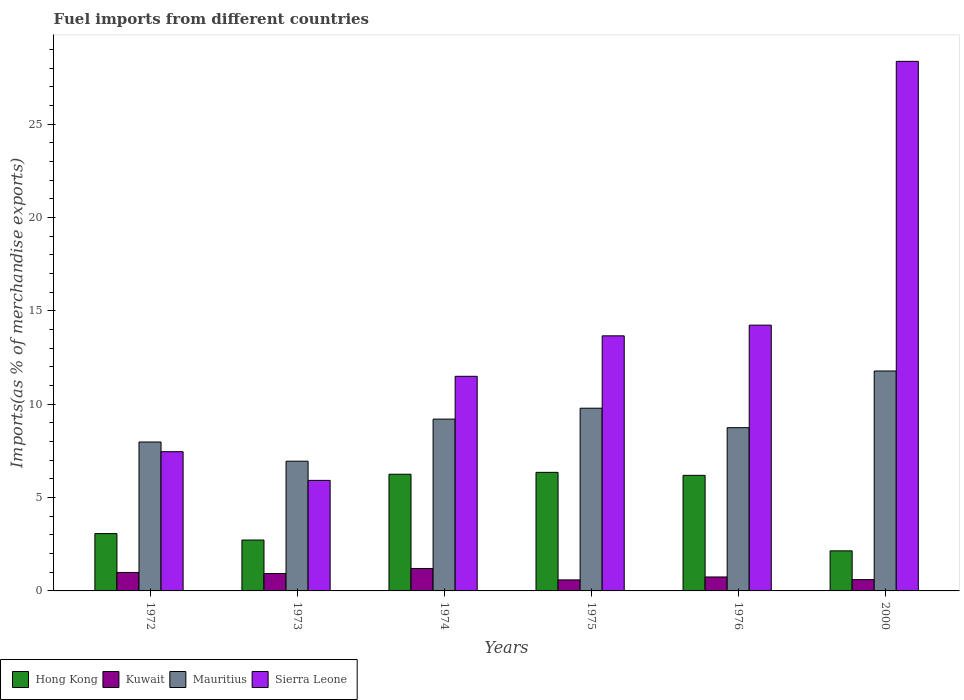How many different coloured bars are there?
Your response must be concise. 4. Are the number of bars per tick equal to the number of legend labels?
Offer a very short reply. Yes. How many bars are there on the 6th tick from the left?
Provide a short and direct response. 4. How many bars are there on the 3rd tick from the right?
Your response must be concise. 4. What is the label of the 5th group of bars from the left?
Make the answer very short. 1976. What is the percentage of imports to different countries in Kuwait in 1974?
Offer a terse response. 1.2. Across all years, what is the maximum percentage of imports to different countries in Hong Kong?
Your answer should be compact. 6.35. Across all years, what is the minimum percentage of imports to different countries in Mauritius?
Give a very brief answer. 6.95. In which year was the percentage of imports to different countries in Kuwait maximum?
Keep it short and to the point. 1974. What is the total percentage of imports to different countries in Sierra Leone in the graph?
Keep it short and to the point. 81.14. What is the difference between the percentage of imports to different countries in Sierra Leone in 1975 and that in 1976?
Give a very brief answer. -0.57. What is the difference between the percentage of imports to different countries in Kuwait in 1975 and the percentage of imports to different countries in Mauritius in 1973?
Provide a short and direct response. -6.36. What is the average percentage of imports to different countries in Mauritius per year?
Offer a terse response. 9.07. In the year 2000, what is the difference between the percentage of imports to different countries in Kuwait and percentage of imports to different countries in Sierra Leone?
Your response must be concise. -27.76. What is the ratio of the percentage of imports to different countries in Hong Kong in 1974 to that in 2000?
Provide a short and direct response. 2.91. Is the percentage of imports to different countries in Hong Kong in 1972 less than that in 1974?
Make the answer very short. Yes. Is the difference between the percentage of imports to different countries in Kuwait in 1972 and 1973 greater than the difference between the percentage of imports to different countries in Sierra Leone in 1972 and 1973?
Your response must be concise. No. What is the difference between the highest and the second highest percentage of imports to different countries in Kuwait?
Provide a succinct answer. 0.21. What is the difference between the highest and the lowest percentage of imports to different countries in Mauritius?
Keep it short and to the point. 4.83. In how many years, is the percentage of imports to different countries in Mauritius greater than the average percentage of imports to different countries in Mauritius taken over all years?
Your response must be concise. 3. What does the 2nd bar from the left in 1972 represents?
Ensure brevity in your answer.  Kuwait. What does the 4th bar from the right in 1973 represents?
Ensure brevity in your answer.  Hong Kong. How many bars are there?
Give a very brief answer. 24. Are all the bars in the graph horizontal?
Keep it short and to the point. No. How many years are there in the graph?
Your answer should be very brief. 6. Are the values on the major ticks of Y-axis written in scientific E-notation?
Make the answer very short. No. Does the graph contain any zero values?
Your answer should be very brief. No. Where does the legend appear in the graph?
Offer a very short reply. Bottom left. What is the title of the graph?
Your answer should be compact. Fuel imports from different countries. What is the label or title of the Y-axis?
Offer a terse response. Imports(as % of merchandise exports). What is the Imports(as % of merchandise exports) of Hong Kong in 1972?
Keep it short and to the point. 3.07. What is the Imports(as % of merchandise exports) in Kuwait in 1972?
Your answer should be compact. 0.99. What is the Imports(as % of merchandise exports) in Mauritius in 1972?
Your answer should be compact. 7.98. What is the Imports(as % of merchandise exports) in Sierra Leone in 1972?
Provide a succinct answer. 7.46. What is the Imports(as % of merchandise exports) of Hong Kong in 1973?
Offer a very short reply. 2.73. What is the Imports(as % of merchandise exports) in Kuwait in 1973?
Keep it short and to the point. 0.93. What is the Imports(as % of merchandise exports) in Mauritius in 1973?
Offer a terse response. 6.95. What is the Imports(as % of merchandise exports) in Sierra Leone in 1973?
Your response must be concise. 5.92. What is the Imports(as % of merchandise exports) in Hong Kong in 1974?
Offer a very short reply. 6.25. What is the Imports(as % of merchandise exports) of Kuwait in 1974?
Provide a succinct answer. 1.2. What is the Imports(as % of merchandise exports) of Mauritius in 1974?
Your answer should be compact. 9.2. What is the Imports(as % of merchandise exports) of Sierra Leone in 1974?
Give a very brief answer. 11.5. What is the Imports(as % of merchandise exports) of Hong Kong in 1975?
Your answer should be compact. 6.35. What is the Imports(as % of merchandise exports) in Kuwait in 1975?
Give a very brief answer. 0.59. What is the Imports(as % of merchandise exports) in Mauritius in 1975?
Your response must be concise. 9.79. What is the Imports(as % of merchandise exports) in Sierra Leone in 1975?
Provide a succinct answer. 13.66. What is the Imports(as % of merchandise exports) of Hong Kong in 1976?
Make the answer very short. 6.19. What is the Imports(as % of merchandise exports) in Kuwait in 1976?
Your answer should be compact. 0.75. What is the Imports(as % of merchandise exports) of Mauritius in 1976?
Make the answer very short. 8.74. What is the Imports(as % of merchandise exports) in Sierra Leone in 1976?
Your answer should be compact. 14.24. What is the Imports(as % of merchandise exports) of Hong Kong in 2000?
Keep it short and to the point. 2.15. What is the Imports(as % of merchandise exports) in Kuwait in 2000?
Offer a terse response. 0.61. What is the Imports(as % of merchandise exports) of Mauritius in 2000?
Offer a terse response. 11.78. What is the Imports(as % of merchandise exports) of Sierra Leone in 2000?
Your answer should be very brief. 28.37. Across all years, what is the maximum Imports(as % of merchandise exports) of Hong Kong?
Offer a terse response. 6.35. Across all years, what is the maximum Imports(as % of merchandise exports) in Kuwait?
Offer a very short reply. 1.2. Across all years, what is the maximum Imports(as % of merchandise exports) in Mauritius?
Offer a very short reply. 11.78. Across all years, what is the maximum Imports(as % of merchandise exports) in Sierra Leone?
Ensure brevity in your answer.  28.37. Across all years, what is the minimum Imports(as % of merchandise exports) of Hong Kong?
Ensure brevity in your answer.  2.15. Across all years, what is the minimum Imports(as % of merchandise exports) of Kuwait?
Your answer should be compact. 0.59. Across all years, what is the minimum Imports(as % of merchandise exports) of Mauritius?
Offer a very short reply. 6.95. Across all years, what is the minimum Imports(as % of merchandise exports) of Sierra Leone?
Make the answer very short. 5.92. What is the total Imports(as % of merchandise exports) in Hong Kong in the graph?
Give a very brief answer. 26.74. What is the total Imports(as % of merchandise exports) of Kuwait in the graph?
Ensure brevity in your answer.  5.07. What is the total Imports(as % of merchandise exports) of Mauritius in the graph?
Keep it short and to the point. 54.44. What is the total Imports(as % of merchandise exports) in Sierra Leone in the graph?
Provide a succinct answer. 81.14. What is the difference between the Imports(as % of merchandise exports) in Hong Kong in 1972 and that in 1973?
Your answer should be compact. 0.35. What is the difference between the Imports(as % of merchandise exports) of Kuwait in 1972 and that in 1973?
Make the answer very short. 0.06. What is the difference between the Imports(as % of merchandise exports) in Mauritius in 1972 and that in 1973?
Ensure brevity in your answer.  1.03. What is the difference between the Imports(as % of merchandise exports) in Sierra Leone in 1972 and that in 1973?
Give a very brief answer. 1.54. What is the difference between the Imports(as % of merchandise exports) of Hong Kong in 1972 and that in 1974?
Your answer should be very brief. -3.18. What is the difference between the Imports(as % of merchandise exports) of Kuwait in 1972 and that in 1974?
Your answer should be very brief. -0.21. What is the difference between the Imports(as % of merchandise exports) of Mauritius in 1972 and that in 1974?
Your response must be concise. -1.23. What is the difference between the Imports(as % of merchandise exports) in Sierra Leone in 1972 and that in 1974?
Your answer should be very brief. -4.04. What is the difference between the Imports(as % of merchandise exports) in Hong Kong in 1972 and that in 1975?
Offer a very short reply. -3.28. What is the difference between the Imports(as % of merchandise exports) of Kuwait in 1972 and that in 1975?
Your response must be concise. 0.4. What is the difference between the Imports(as % of merchandise exports) of Mauritius in 1972 and that in 1975?
Keep it short and to the point. -1.81. What is the difference between the Imports(as % of merchandise exports) of Sierra Leone in 1972 and that in 1975?
Offer a terse response. -6.21. What is the difference between the Imports(as % of merchandise exports) in Hong Kong in 1972 and that in 1976?
Your response must be concise. -3.12. What is the difference between the Imports(as % of merchandise exports) of Kuwait in 1972 and that in 1976?
Your response must be concise. 0.24. What is the difference between the Imports(as % of merchandise exports) of Mauritius in 1972 and that in 1976?
Ensure brevity in your answer.  -0.77. What is the difference between the Imports(as % of merchandise exports) of Sierra Leone in 1972 and that in 1976?
Ensure brevity in your answer.  -6.78. What is the difference between the Imports(as % of merchandise exports) of Hong Kong in 1972 and that in 2000?
Your answer should be compact. 0.93. What is the difference between the Imports(as % of merchandise exports) of Kuwait in 1972 and that in 2000?
Your response must be concise. 0.39. What is the difference between the Imports(as % of merchandise exports) in Mauritius in 1972 and that in 2000?
Provide a short and direct response. -3.8. What is the difference between the Imports(as % of merchandise exports) of Sierra Leone in 1972 and that in 2000?
Give a very brief answer. -20.91. What is the difference between the Imports(as % of merchandise exports) in Hong Kong in 1973 and that in 1974?
Your answer should be compact. -3.52. What is the difference between the Imports(as % of merchandise exports) of Kuwait in 1973 and that in 1974?
Offer a terse response. -0.27. What is the difference between the Imports(as % of merchandise exports) of Mauritius in 1973 and that in 1974?
Provide a succinct answer. -2.25. What is the difference between the Imports(as % of merchandise exports) in Sierra Leone in 1973 and that in 1974?
Your answer should be compact. -5.57. What is the difference between the Imports(as % of merchandise exports) of Hong Kong in 1973 and that in 1975?
Provide a succinct answer. -3.63. What is the difference between the Imports(as % of merchandise exports) in Kuwait in 1973 and that in 1975?
Your answer should be very brief. 0.34. What is the difference between the Imports(as % of merchandise exports) in Mauritius in 1973 and that in 1975?
Ensure brevity in your answer.  -2.84. What is the difference between the Imports(as % of merchandise exports) in Sierra Leone in 1973 and that in 1975?
Give a very brief answer. -7.74. What is the difference between the Imports(as % of merchandise exports) of Hong Kong in 1973 and that in 1976?
Provide a short and direct response. -3.46. What is the difference between the Imports(as % of merchandise exports) of Kuwait in 1973 and that in 1976?
Provide a succinct answer. 0.18. What is the difference between the Imports(as % of merchandise exports) of Mauritius in 1973 and that in 1976?
Provide a succinct answer. -1.8. What is the difference between the Imports(as % of merchandise exports) in Sierra Leone in 1973 and that in 1976?
Give a very brief answer. -8.31. What is the difference between the Imports(as % of merchandise exports) of Hong Kong in 1973 and that in 2000?
Your answer should be very brief. 0.58. What is the difference between the Imports(as % of merchandise exports) in Kuwait in 1973 and that in 2000?
Ensure brevity in your answer.  0.33. What is the difference between the Imports(as % of merchandise exports) in Mauritius in 1973 and that in 2000?
Give a very brief answer. -4.83. What is the difference between the Imports(as % of merchandise exports) of Sierra Leone in 1973 and that in 2000?
Provide a short and direct response. -22.44. What is the difference between the Imports(as % of merchandise exports) in Hong Kong in 1974 and that in 1975?
Give a very brief answer. -0.1. What is the difference between the Imports(as % of merchandise exports) in Kuwait in 1974 and that in 1975?
Offer a very short reply. 0.61. What is the difference between the Imports(as % of merchandise exports) of Mauritius in 1974 and that in 1975?
Offer a very short reply. -0.58. What is the difference between the Imports(as % of merchandise exports) in Sierra Leone in 1974 and that in 1975?
Make the answer very short. -2.17. What is the difference between the Imports(as % of merchandise exports) in Hong Kong in 1974 and that in 1976?
Keep it short and to the point. 0.06. What is the difference between the Imports(as % of merchandise exports) of Kuwait in 1974 and that in 1976?
Give a very brief answer. 0.46. What is the difference between the Imports(as % of merchandise exports) of Mauritius in 1974 and that in 1976?
Your response must be concise. 0.46. What is the difference between the Imports(as % of merchandise exports) of Sierra Leone in 1974 and that in 1976?
Keep it short and to the point. -2.74. What is the difference between the Imports(as % of merchandise exports) in Hong Kong in 1974 and that in 2000?
Provide a short and direct response. 4.1. What is the difference between the Imports(as % of merchandise exports) of Kuwait in 1974 and that in 2000?
Your answer should be very brief. 0.6. What is the difference between the Imports(as % of merchandise exports) of Mauritius in 1974 and that in 2000?
Give a very brief answer. -2.58. What is the difference between the Imports(as % of merchandise exports) of Sierra Leone in 1974 and that in 2000?
Make the answer very short. -16.87. What is the difference between the Imports(as % of merchandise exports) of Hong Kong in 1975 and that in 1976?
Offer a terse response. 0.16. What is the difference between the Imports(as % of merchandise exports) of Kuwait in 1975 and that in 1976?
Offer a very short reply. -0.16. What is the difference between the Imports(as % of merchandise exports) in Mauritius in 1975 and that in 1976?
Make the answer very short. 1.04. What is the difference between the Imports(as % of merchandise exports) of Sierra Leone in 1975 and that in 1976?
Give a very brief answer. -0.57. What is the difference between the Imports(as % of merchandise exports) in Hong Kong in 1975 and that in 2000?
Your answer should be very brief. 4.2. What is the difference between the Imports(as % of merchandise exports) in Kuwait in 1975 and that in 2000?
Your answer should be compact. -0.01. What is the difference between the Imports(as % of merchandise exports) in Mauritius in 1975 and that in 2000?
Your answer should be very brief. -1.99. What is the difference between the Imports(as % of merchandise exports) in Sierra Leone in 1975 and that in 2000?
Offer a very short reply. -14.7. What is the difference between the Imports(as % of merchandise exports) in Hong Kong in 1976 and that in 2000?
Offer a terse response. 4.04. What is the difference between the Imports(as % of merchandise exports) of Kuwait in 1976 and that in 2000?
Make the answer very short. 0.14. What is the difference between the Imports(as % of merchandise exports) in Mauritius in 1976 and that in 2000?
Make the answer very short. -3.04. What is the difference between the Imports(as % of merchandise exports) in Sierra Leone in 1976 and that in 2000?
Give a very brief answer. -14.13. What is the difference between the Imports(as % of merchandise exports) in Hong Kong in 1972 and the Imports(as % of merchandise exports) in Kuwait in 1973?
Give a very brief answer. 2.14. What is the difference between the Imports(as % of merchandise exports) of Hong Kong in 1972 and the Imports(as % of merchandise exports) of Mauritius in 1973?
Keep it short and to the point. -3.88. What is the difference between the Imports(as % of merchandise exports) of Hong Kong in 1972 and the Imports(as % of merchandise exports) of Sierra Leone in 1973?
Offer a very short reply. -2.85. What is the difference between the Imports(as % of merchandise exports) of Kuwait in 1972 and the Imports(as % of merchandise exports) of Mauritius in 1973?
Provide a short and direct response. -5.96. What is the difference between the Imports(as % of merchandise exports) of Kuwait in 1972 and the Imports(as % of merchandise exports) of Sierra Leone in 1973?
Provide a short and direct response. -4.93. What is the difference between the Imports(as % of merchandise exports) of Mauritius in 1972 and the Imports(as % of merchandise exports) of Sierra Leone in 1973?
Make the answer very short. 2.06. What is the difference between the Imports(as % of merchandise exports) in Hong Kong in 1972 and the Imports(as % of merchandise exports) in Kuwait in 1974?
Keep it short and to the point. 1.87. What is the difference between the Imports(as % of merchandise exports) of Hong Kong in 1972 and the Imports(as % of merchandise exports) of Mauritius in 1974?
Ensure brevity in your answer.  -6.13. What is the difference between the Imports(as % of merchandise exports) in Hong Kong in 1972 and the Imports(as % of merchandise exports) in Sierra Leone in 1974?
Offer a very short reply. -8.42. What is the difference between the Imports(as % of merchandise exports) of Kuwait in 1972 and the Imports(as % of merchandise exports) of Mauritius in 1974?
Your answer should be compact. -8.21. What is the difference between the Imports(as % of merchandise exports) in Kuwait in 1972 and the Imports(as % of merchandise exports) in Sierra Leone in 1974?
Offer a terse response. -10.51. What is the difference between the Imports(as % of merchandise exports) of Mauritius in 1972 and the Imports(as % of merchandise exports) of Sierra Leone in 1974?
Keep it short and to the point. -3.52. What is the difference between the Imports(as % of merchandise exports) in Hong Kong in 1972 and the Imports(as % of merchandise exports) in Kuwait in 1975?
Offer a terse response. 2.48. What is the difference between the Imports(as % of merchandise exports) in Hong Kong in 1972 and the Imports(as % of merchandise exports) in Mauritius in 1975?
Offer a very short reply. -6.72. What is the difference between the Imports(as % of merchandise exports) in Hong Kong in 1972 and the Imports(as % of merchandise exports) in Sierra Leone in 1975?
Make the answer very short. -10.59. What is the difference between the Imports(as % of merchandise exports) of Kuwait in 1972 and the Imports(as % of merchandise exports) of Mauritius in 1975?
Keep it short and to the point. -8.8. What is the difference between the Imports(as % of merchandise exports) of Kuwait in 1972 and the Imports(as % of merchandise exports) of Sierra Leone in 1975?
Make the answer very short. -12.67. What is the difference between the Imports(as % of merchandise exports) in Mauritius in 1972 and the Imports(as % of merchandise exports) in Sierra Leone in 1975?
Give a very brief answer. -5.69. What is the difference between the Imports(as % of merchandise exports) of Hong Kong in 1972 and the Imports(as % of merchandise exports) of Kuwait in 1976?
Your answer should be very brief. 2.32. What is the difference between the Imports(as % of merchandise exports) of Hong Kong in 1972 and the Imports(as % of merchandise exports) of Mauritius in 1976?
Make the answer very short. -5.67. What is the difference between the Imports(as % of merchandise exports) in Hong Kong in 1972 and the Imports(as % of merchandise exports) in Sierra Leone in 1976?
Ensure brevity in your answer.  -11.16. What is the difference between the Imports(as % of merchandise exports) of Kuwait in 1972 and the Imports(as % of merchandise exports) of Mauritius in 1976?
Provide a succinct answer. -7.75. What is the difference between the Imports(as % of merchandise exports) in Kuwait in 1972 and the Imports(as % of merchandise exports) in Sierra Leone in 1976?
Give a very brief answer. -13.24. What is the difference between the Imports(as % of merchandise exports) of Mauritius in 1972 and the Imports(as % of merchandise exports) of Sierra Leone in 1976?
Keep it short and to the point. -6.26. What is the difference between the Imports(as % of merchandise exports) in Hong Kong in 1972 and the Imports(as % of merchandise exports) in Kuwait in 2000?
Make the answer very short. 2.47. What is the difference between the Imports(as % of merchandise exports) of Hong Kong in 1972 and the Imports(as % of merchandise exports) of Mauritius in 2000?
Keep it short and to the point. -8.71. What is the difference between the Imports(as % of merchandise exports) of Hong Kong in 1972 and the Imports(as % of merchandise exports) of Sierra Leone in 2000?
Keep it short and to the point. -25.29. What is the difference between the Imports(as % of merchandise exports) of Kuwait in 1972 and the Imports(as % of merchandise exports) of Mauritius in 2000?
Your response must be concise. -10.79. What is the difference between the Imports(as % of merchandise exports) in Kuwait in 1972 and the Imports(as % of merchandise exports) in Sierra Leone in 2000?
Offer a very short reply. -27.38. What is the difference between the Imports(as % of merchandise exports) in Mauritius in 1972 and the Imports(as % of merchandise exports) in Sierra Leone in 2000?
Provide a short and direct response. -20.39. What is the difference between the Imports(as % of merchandise exports) in Hong Kong in 1973 and the Imports(as % of merchandise exports) in Kuwait in 1974?
Make the answer very short. 1.52. What is the difference between the Imports(as % of merchandise exports) in Hong Kong in 1973 and the Imports(as % of merchandise exports) in Mauritius in 1974?
Provide a short and direct response. -6.48. What is the difference between the Imports(as % of merchandise exports) in Hong Kong in 1973 and the Imports(as % of merchandise exports) in Sierra Leone in 1974?
Your answer should be compact. -8.77. What is the difference between the Imports(as % of merchandise exports) in Kuwait in 1973 and the Imports(as % of merchandise exports) in Mauritius in 1974?
Your response must be concise. -8.27. What is the difference between the Imports(as % of merchandise exports) of Kuwait in 1973 and the Imports(as % of merchandise exports) of Sierra Leone in 1974?
Your answer should be compact. -10.57. What is the difference between the Imports(as % of merchandise exports) of Mauritius in 1973 and the Imports(as % of merchandise exports) of Sierra Leone in 1974?
Offer a terse response. -4.55. What is the difference between the Imports(as % of merchandise exports) of Hong Kong in 1973 and the Imports(as % of merchandise exports) of Kuwait in 1975?
Your answer should be compact. 2.14. What is the difference between the Imports(as % of merchandise exports) in Hong Kong in 1973 and the Imports(as % of merchandise exports) in Mauritius in 1975?
Make the answer very short. -7.06. What is the difference between the Imports(as % of merchandise exports) in Hong Kong in 1973 and the Imports(as % of merchandise exports) in Sierra Leone in 1975?
Your answer should be compact. -10.94. What is the difference between the Imports(as % of merchandise exports) of Kuwait in 1973 and the Imports(as % of merchandise exports) of Mauritius in 1975?
Keep it short and to the point. -8.86. What is the difference between the Imports(as % of merchandise exports) of Kuwait in 1973 and the Imports(as % of merchandise exports) of Sierra Leone in 1975?
Offer a terse response. -12.73. What is the difference between the Imports(as % of merchandise exports) of Mauritius in 1973 and the Imports(as % of merchandise exports) of Sierra Leone in 1975?
Your answer should be compact. -6.71. What is the difference between the Imports(as % of merchandise exports) of Hong Kong in 1973 and the Imports(as % of merchandise exports) of Kuwait in 1976?
Make the answer very short. 1.98. What is the difference between the Imports(as % of merchandise exports) of Hong Kong in 1973 and the Imports(as % of merchandise exports) of Mauritius in 1976?
Your answer should be very brief. -6.02. What is the difference between the Imports(as % of merchandise exports) of Hong Kong in 1973 and the Imports(as % of merchandise exports) of Sierra Leone in 1976?
Provide a succinct answer. -11.51. What is the difference between the Imports(as % of merchandise exports) of Kuwait in 1973 and the Imports(as % of merchandise exports) of Mauritius in 1976?
Your answer should be compact. -7.81. What is the difference between the Imports(as % of merchandise exports) of Kuwait in 1973 and the Imports(as % of merchandise exports) of Sierra Leone in 1976?
Provide a succinct answer. -13.31. What is the difference between the Imports(as % of merchandise exports) in Mauritius in 1973 and the Imports(as % of merchandise exports) in Sierra Leone in 1976?
Your response must be concise. -7.29. What is the difference between the Imports(as % of merchandise exports) in Hong Kong in 1973 and the Imports(as % of merchandise exports) in Kuwait in 2000?
Your response must be concise. 2.12. What is the difference between the Imports(as % of merchandise exports) of Hong Kong in 1973 and the Imports(as % of merchandise exports) of Mauritius in 2000?
Make the answer very short. -9.05. What is the difference between the Imports(as % of merchandise exports) in Hong Kong in 1973 and the Imports(as % of merchandise exports) in Sierra Leone in 2000?
Your answer should be very brief. -25.64. What is the difference between the Imports(as % of merchandise exports) of Kuwait in 1973 and the Imports(as % of merchandise exports) of Mauritius in 2000?
Provide a succinct answer. -10.85. What is the difference between the Imports(as % of merchandise exports) in Kuwait in 1973 and the Imports(as % of merchandise exports) in Sierra Leone in 2000?
Ensure brevity in your answer.  -27.44. What is the difference between the Imports(as % of merchandise exports) in Mauritius in 1973 and the Imports(as % of merchandise exports) in Sierra Leone in 2000?
Give a very brief answer. -21.42. What is the difference between the Imports(as % of merchandise exports) of Hong Kong in 1974 and the Imports(as % of merchandise exports) of Kuwait in 1975?
Your answer should be compact. 5.66. What is the difference between the Imports(as % of merchandise exports) of Hong Kong in 1974 and the Imports(as % of merchandise exports) of Mauritius in 1975?
Give a very brief answer. -3.54. What is the difference between the Imports(as % of merchandise exports) in Hong Kong in 1974 and the Imports(as % of merchandise exports) in Sierra Leone in 1975?
Offer a terse response. -7.41. What is the difference between the Imports(as % of merchandise exports) of Kuwait in 1974 and the Imports(as % of merchandise exports) of Mauritius in 1975?
Provide a short and direct response. -8.58. What is the difference between the Imports(as % of merchandise exports) in Kuwait in 1974 and the Imports(as % of merchandise exports) in Sierra Leone in 1975?
Your response must be concise. -12.46. What is the difference between the Imports(as % of merchandise exports) of Mauritius in 1974 and the Imports(as % of merchandise exports) of Sierra Leone in 1975?
Keep it short and to the point. -4.46. What is the difference between the Imports(as % of merchandise exports) of Hong Kong in 1974 and the Imports(as % of merchandise exports) of Kuwait in 1976?
Make the answer very short. 5.5. What is the difference between the Imports(as % of merchandise exports) of Hong Kong in 1974 and the Imports(as % of merchandise exports) of Mauritius in 1976?
Your response must be concise. -2.49. What is the difference between the Imports(as % of merchandise exports) of Hong Kong in 1974 and the Imports(as % of merchandise exports) of Sierra Leone in 1976?
Provide a succinct answer. -7.99. What is the difference between the Imports(as % of merchandise exports) in Kuwait in 1974 and the Imports(as % of merchandise exports) in Mauritius in 1976?
Provide a succinct answer. -7.54. What is the difference between the Imports(as % of merchandise exports) in Kuwait in 1974 and the Imports(as % of merchandise exports) in Sierra Leone in 1976?
Offer a terse response. -13.03. What is the difference between the Imports(as % of merchandise exports) in Mauritius in 1974 and the Imports(as % of merchandise exports) in Sierra Leone in 1976?
Your answer should be very brief. -5.03. What is the difference between the Imports(as % of merchandise exports) of Hong Kong in 1974 and the Imports(as % of merchandise exports) of Kuwait in 2000?
Provide a short and direct response. 5.65. What is the difference between the Imports(as % of merchandise exports) in Hong Kong in 1974 and the Imports(as % of merchandise exports) in Mauritius in 2000?
Provide a succinct answer. -5.53. What is the difference between the Imports(as % of merchandise exports) of Hong Kong in 1974 and the Imports(as % of merchandise exports) of Sierra Leone in 2000?
Your answer should be compact. -22.12. What is the difference between the Imports(as % of merchandise exports) in Kuwait in 1974 and the Imports(as % of merchandise exports) in Mauritius in 2000?
Offer a terse response. -10.58. What is the difference between the Imports(as % of merchandise exports) of Kuwait in 1974 and the Imports(as % of merchandise exports) of Sierra Leone in 2000?
Your answer should be compact. -27.16. What is the difference between the Imports(as % of merchandise exports) in Mauritius in 1974 and the Imports(as % of merchandise exports) in Sierra Leone in 2000?
Your answer should be very brief. -19.16. What is the difference between the Imports(as % of merchandise exports) in Hong Kong in 1975 and the Imports(as % of merchandise exports) in Kuwait in 1976?
Offer a very short reply. 5.6. What is the difference between the Imports(as % of merchandise exports) of Hong Kong in 1975 and the Imports(as % of merchandise exports) of Mauritius in 1976?
Provide a succinct answer. -2.39. What is the difference between the Imports(as % of merchandise exports) in Hong Kong in 1975 and the Imports(as % of merchandise exports) in Sierra Leone in 1976?
Provide a short and direct response. -7.88. What is the difference between the Imports(as % of merchandise exports) in Kuwait in 1975 and the Imports(as % of merchandise exports) in Mauritius in 1976?
Keep it short and to the point. -8.15. What is the difference between the Imports(as % of merchandise exports) of Kuwait in 1975 and the Imports(as % of merchandise exports) of Sierra Leone in 1976?
Your answer should be very brief. -13.65. What is the difference between the Imports(as % of merchandise exports) of Mauritius in 1975 and the Imports(as % of merchandise exports) of Sierra Leone in 1976?
Your answer should be very brief. -4.45. What is the difference between the Imports(as % of merchandise exports) in Hong Kong in 1975 and the Imports(as % of merchandise exports) in Kuwait in 2000?
Give a very brief answer. 5.75. What is the difference between the Imports(as % of merchandise exports) of Hong Kong in 1975 and the Imports(as % of merchandise exports) of Mauritius in 2000?
Keep it short and to the point. -5.43. What is the difference between the Imports(as % of merchandise exports) of Hong Kong in 1975 and the Imports(as % of merchandise exports) of Sierra Leone in 2000?
Give a very brief answer. -22.02. What is the difference between the Imports(as % of merchandise exports) in Kuwait in 1975 and the Imports(as % of merchandise exports) in Mauritius in 2000?
Ensure brevity in your answer.  -11.19. What is the difference between the Imports(as % of merchandise exports) of Kuwait in 1975 and the Imports(as % of merchandise exports) of Sierra Leone in 2000?
Offer a very short reply. -27.78. What is the difference between the Imports(as % of merchandise exports) of Mauritius in 1975 and the Imports(as % of merchandise exports) of Sierra Leone in 2000?
Your response must be concise. -18.58. What is the difference between the Imports(as % of merchandise exports) of Hong Kong in 1976 and the Imports(as % of merchandise exports) of Kuwait in 2000?
Make the answer very short. 5.59. What is the difference between the Imports(as % of merchandise exports) of Hong Kong in 1976 and the Imports(as % of merchandise exports) of Mauritius in 2000?
Your response must be concise. -5.59. What is the difference between the Imports(as % of merchandise exports) of Hong Kong in 1976 and the Imports(as % of merchandise exports) of Sierra Leone in 2000?
Offer a terse response. -22.18. What is the difference between the Imports(as % of merchandise exports) in Kuwait in 1976 and the Imports(as % of merchandise exports) in Mauritius in 2000?
Ensure brevity in your answer.  -11.03. What is the difference between the Imports(as % of merchandise exports) in Kuwait in 1976 and the Imports(as % of merchandise exports) in Sierra Leone in 2000?
Your response must be concise. -27.62. What is the difference between the Imports(as % of merchandise exports) of Mauritius in 1976 and the Imports(as % of merchandise exports) of Sierra Leone in 2000?
Give a very brief answer. -19.62. What is the average Imports(as % of merchandise exports) in Hong Kong per year?
Your response must be concise. 4.46. What is the average Imports(as % of merchandise exports) in Kuwait per year?
Offer a terse response. 0.84. What is the average Imports(as % of merchandise exports) in Mauritius per year?
Offer a very short reply. 9.07. What is the average Imports(as % of merchandise exports) of Sierra Leone per year?
Your response must be concise. 13.52. In the year 1972, what is the difference between the Imports(as % of merchandise exports) of Hong Kong and Imports(as % of merchandise exports) of Kuwait?
Offer a terse response. 2.08. In the year 1972, what is the difference between the Imports(as % of merchandise exports) in Hong Kong and Imports(as % of merchandise exports) in Mauritius?
Make the answer very short. -4.91. In the year 1972, what is the difference between the Imports(as % of merchandise exports) of Hong Kong and Imports(as % of merchandise exports) of Sierra Leone?
Give a very brief answer. -4.39. In the year 1972, what is the difference between the Imports(as % of merchandise exports) in Kuwait and Imports(as % of merchandise exports) in Mauritius?
Offer a terse response. -6.99. In the year 1972, what is the difference between the Imports(as % of merchandise exports) of Kuwait and Imports(as % of merchandise exports) of Sierra Leone?
Provide a short and direct response. -6.47. In the year 1972, what is the difference between the Imports(as % of merchandise exports) of Mauritius and Imports(as % of merchandise exports) of Sierra Leone?
Give a very brief answer. 0.52. In the year 1973, what is the difference between the Imports(as % of merchandise exports) in Hong Kong and Imports(as % of merchandise exports) in Kuwait?
Your answer should be very brief. 1.8. In the year 1973, what is the difference between the Imports(as % of merchandise exports) of Hong Kong and Imports(as % of merchandise exports) of Mauritius?
Keep it short and to the point. -4.22. In the year 1973, what is the difference between the Imports(as % of merchandise exports) in Hong Kong and Imports(as % of merchandise exports) in Sierra Leone?
Your answer should be very brief. -3.2. In the year 1973, what is the difference between the Imports(as % of merchandise exports) of Kuwait and Imports(as % of merchandise exports) of Mauritius?
Keep it short and to the point. -6.02. In the year 1973, what is the difference between the Imports(as % of merchandise exports) of Kuwait and Imports(as % of merchandise exports) of Sierra Leone?
Offer a terse response. -4.99. In the year 1973, what is the difference between the Imports(as % of merchandise exports) in Mauritius and Imports(as % of merchandise exports) in Sierra Leone?
Give a very brief answer. 1.03. In the year 1974, what is the difference between the Imports(as % of merchandise exports) of Hong Kong and Imports(as % of merchandise exports) of Kuwait?
Make the answer very short. 5.05. In the year 1974, what is the difference between the Imports(as % of merchandise exports) in Hong Kong and Imports(as % of merchandise exports) in Mauritius?
Provide a short and direct response. -2.95. In the year 1974, what is the difference between the Imports(as % of merchandise exports) in Hong Kong and Imports(as % of merchandise exports) in Sierra Leone?
Ensure brevity in your answer.  -5.25. In the year 1974, what is the difference between the Imports(as % of merchandise exports) of Kuwait and Imports(as % of merchandise exports) of Mauritius?
Provide a succinct answer. -8. In the year 1974, what is the difference between the Imports(as % of merchandise exports) in Kuwait and Imports(as % of merchandise exports) in Sierra Leone?
Your answer should be very brief. -10.29. In the year 1974, what is the difference between the Imports(as % of merchandise exports) in Mauritius and Imports(as % of merchandise exports) in Sierra Leone?
Offer a very short reply. -2.29. In the year 1975, what is the difference between the Imports(as % of merchandise exports) of Hong Kong and Imports(as % of merchandise exports) of Kuwait?
Offer a very short reply. 5.76. In the year 1975, what is the difference between the Imports(as % of merchandise exports) in Hong Kong and Imports(as % of merchandise exports) in Mauritius?
Ensure brevity in your answer.  -3.44. In the year 1975, what is the difference between the Imports(as % of merchandise exports) in Hong Kong and Imports(as % of merchandise exports) in Sierra Leone?
Provide a short and direct response. -7.31. In the year 1975, what is the difference between the Imports(as % of merchandise exports) in Kuwait and Imports(as % of merchandise exports) in Mauritius?
Offer a terse response. -9.2. In the year 1975, what is the difference between the Imports(as % of merchandise exports) in Kuwait and Imports(as % of merchandise exports) in Sierra Leone?
Provide a short and direct response. -13.07. In the year 1975, what is the difference between the Imports(as % of merchandise exports) of Mauritius and Imports(as % of merchandise exports) of Sierra Leone?
Your answer should be very brief. -3.88. In the year 1976, what is the difference between the Imports(as % of merchandise exports) of Hong Kong and Imports(as % of merchandise exports) of Kuwait?
Give a very brief answer. 5.44. In the year 1976, what is the difference between the Imports(as % of merchandise exports) of Hong Kong and Imports(as % of merchandise exports) of Mauritius?
Offer a terse response. -2.55. In the year 1976, what is the difference between the Imports(as % of merchandise exports) in Hong Kong and Imports(as % of merchandise exports) in Sierra Leone?
Ensure brevity in your answer.  -8.04. In the year 1976, what is the difference between the Imports(as % of merchandise exports) of Kuwait and Imports(as % of merchandise exports) of Mauritius?
Provide a succinct answer. -8. In the year 1976, what is the difference between the Imports(as % of merchandise exports) in Kuwait and Imports(as % of merchandise exports) in Sierra Leone?
Give a very brief answer. -13.49. In the year 1976, what is the difference between the Imports(as % of merchandise exports) in Mauritius and Imports(as % of merchandise exports) in Sierra Leone?
Make the answer very short. -5.49. In the year 2000, what is the difference between the Imports(as % of merchandise exports) of Hong Kong and Imports(as % of merchandise exports) of Kuwait?
Give a very brief answer. 1.54. In the year 2000, what is the difference between the Imports(as % of merchandise exports) of Hong Kong and Imports(as % of merchandise exports) of Mauritius?
Provide a succinct answer. -9.63. In the year 2000, what is the difference between the Imports(as % of merchandise exports) of Hong Kong and Imports(as % of merchandise exports) of Sierra Leone?
Ensure brevity in your answer.  -26.22. In the year 2000, what is the difference between the Imports(as % of merchandise exports) of Kuwait and Imports(as % of merchandise exports) of Mauritius?
Make the answer very short. -11.18. In the year 2000, what is the difference between the Imports(as % of merchandise exports) in Kuwait and Imports(as % of merchandise exports) in Sierra Leone?
Provide a short and direct response. -27.76. In the year 2000, what is the difference between the Imports(as % of merchandise exports) of Mauritius and Imports(as % of merchandise exports) of Sierra Leone?
Make the answer very short. -16.59. What is the ratio of the Imports(as % of merchandise exports) of Hong Kong in 1972 to that in 1973?
Ensure brevity in your answer.  1.13. What is the ratio of the Imports(as % of merchandise exports) of Kuwait in 1972 to that in 1973?
Your response must be concise. 1.07. What is the ratio of the Imports(as % of merchandise exports) of Mauritius in 1972 to that in 1973?
Make the answer very short. 1.15. What is the ratio of the Imports(as % of merchandise exports) of Sierra Leone in 1972 to that in 1973?
Provide a short and direct response. 1.26. What is the ratio of the Imports(as % of merchandise exports) of Hong Kong in 1972 to that in 1974?
Offer a very short reply. 0.49. What is the ratio of the Imports(as % of merchandise exports) of Kuwait in 1972 to that in 1974?
Your response must be concise. 0.82. What is the ratio of the Imports(as % of merchandise exports) in Mauritius in 1972 to that in 1974?
Ensure brevity in your answer.  0.87. What is the ratio of the Imports(as % of merchandise exports) of Sierra Leone in 1972 to that in 1974?
Your answer should be compact. 0.65. What is the ratio of the Imports(as % of merchandise exports) of Hong Kong in 1972 to that in 1975?
Your response must be concise. 0.48. What is the ratio of the Imports(as % of merchandise exports) in Kuwait in 1972 to that in 1975?
Your response must be concise. 1.68. What is the ratio of the Imports(as % of merchandise exports) in Mauritius in 1972 to that in 1975?
Keep it short and to the point. 0.82. What is the ratio of the Imports(as % of merchandise exports) in Sierra Leone in 1972 to that in 1975?
Make the answer very short. 0.55. What is the ratio of the Imports(as % of merchandise exports) in Hong Kong in 1972 to that in 1976?
Make the answer very short. 0.5. What is the ratio of the Imports(as % of merchandise exports) of Kuwait in 1972 to that in 1976?
Give a very brief answer. 1.33. What is the ratio of the Imports(as % of merchandise exports) of Mauritius in 1972 to that in 1976?
Your answer should be compact. 0.91. What is the ratio of the Imports(as % of merchandise exports) of Sierra Leone in 1972 to that in 1976?
Offer a terse response. 0.52. What is the ratio of the Imports(as % of merchandise exports) in Hong Kong in 1972 to that in 2000?
Ensure brevity in your answer.  1.43. What is the ratio of the Imports(as % of merchandise exports) of Kuwait in 1972 to that in 2000?
Provide a short and direct response. 1.64. What is the ratio of the Imports(as % of merchandise exports) of Mauritius in 1972 to that in 2000?
Your response must be concise. 0.68. What is the ratio of the Imports(as % of merchandise exports) in Sierra Leone in 1972 to that in 2000?
Offer a terse response. 0.26. What is the ratio of the Imports(as % of merchandise exports) in Hong Kong in 1973 to that in 1974?
Provide a short and direct response. 0.44. What is the ratio of the Imports(as % of merchandise exports) in Kuwait in 1973 to that in 1974?
Ensure brevity in your answer.  0.77. What is the ratio of the Imports(as % of merchandise exports) in Mauritius in 1973 to that in 1974?
Your answer should be compact. 0.76. What is the ratio of the Imports(as % of merchandise exports) in Sierra Leone in 1973 to that in 1974?
Make the answer very short. 0.52. What is the ratio of the Imports(as % of merchandise exports) in Hong Kong in 1973 to that in 1975?
Offer a terse response. 0.43. What is the ratio of the Imports(as % of merchandise exports) of Kuwait in 1973 to that in 1975?
Offer a terse response. 1.58. What is the ratio of the Imports(as % of merchandise exports) of Mauritius in 1973 to that in 1975?
Your response must be concise. 0.71. What is the ratio of the Imports(as % of merchandise exports) in Sierra Leone in 1973 to that in 1975?
Make the answer very short. 0.43. What is the ratio of the Imports(as % of merchandise exports) of Hong Kong in 1973 to that in 1976?
Offer a terse response. 0.44. What is the ratio of the Imports(as % of merchandise exports) of Kuwait in 1973 to that in 1976?
Offer a terse response. 1.25. What is the ratio of the Imports(as % of merchandise exports) in Mauritius in 1973 to that in 1976?
Your answer should be very brief. 0.79. What is the ratio of the Imports(as % of merchandise exports) of Sierra Leone in 1973 to that in 1976?
Provide a succinct answer. 0.42. What is the ratio of the Imports(as % of merchandise exports) in Hong Kong in 1973 to that in 2000?
Your answer should be compact. 1.27. What is the ratio of the Imports(as % of merchandise exports) in Kuwait in 1973 to that in 2000?
Ensure brevity in your answer.  1.54. What is the ratio of the Imports(as % of merchandise exports) of Mauritius in 1973 to that in 2000?
Keep it short and to the point. 0.59. What is the ratio of the Imports(as % of merchandise exports) in Sierra Leone in 1973 to that in 2000?
Offer a very short reply. 0.21. What is the ratio of the Imports(as % of merchandise exports) in Hong Kong in 1974 to that in 1975?
Your answer should be compact. 0.98. What is the ratio of the Imports(as % of merchandise exports) of Kuwait in 1974 to that in 1975?
Make the answer very short. 2.04. What is the ratio of the Imports(as % of merchandise exports) of Mauritius in 1974 to that in 1975?
Keep it short and to the point. 0.94. What is the ratio of the Imports(as % of merchandise exports) of Sierra Leone in 1974 to that in 1975?
Give a very brief answer. 0.84. What is the ratio of the Imports(as % of merchandise exports) in Hong Kong in 1974 to that in 1976?
Provide a succinct answer. 1.01. What is the ratio of the Imports(as % of merchandise exports) in Kuwait in 1974 to that in 1976?
Provide a short and direct response. 1.61. What is the ratio of the Imports(as % of merchandise exports) in Mauritius in 1974 to that in 1976?
Your answer should be very brief. 1.05. What is the ratio of the Imports(as % of merchandise exports) of Sierra Leone in 1974 to that in 1976?
Provide a succinct answer. 0.81. What is the ratio of the Imports(as % of merchandise exports) of Hong Kong in 1974 to that in 2000?
Your answer should be very brief. 2.91. What is the ratio of the Imports(as % of merchandise exports) in Kuwait in 1974 to that in 2000?
Offer a terse response. 1.99. What is the ratio of the Imports(as % of merchandise exports) of Mauritius in 1974 to that in 2000?
Your answer should be very brief. 0.78. What is the ratio of the Imports(as % of merchandise exports) in Sierra Leone in 1974 to that in 2000?
Your answer should be compact. 0.41. What is the ratio of the Imports(as % of merchandise exports) of Hong Kong in 1975 to that in 1976?
Your answer should be very brief. 1.03. What is the ratio of the Imports(as % of merchandise exports) in Kuwait in 1975 to that in 1976?
Provide a short and direct response. 0.79. What is the ratio of the Imports(as % of merchandise exports) of Mauritius in 1975 to that in 1976?
Offer a terse response. 1.12. What is the ratio of the Imports(as % of merchandise exports) of Sierra Leone in 1975 to that in 1976?
Offer a very short reply. 0.96. What is the ratio of the Imports(as % of merchandise exports) of Hong Kong in 1975 to that in 2000?
Keep it short and to the point. 2.96. What is the ratio of the Imports(as % of merchandise exports) in Kuwait in 1975 to that in 2000?
Give a very brief answer. 0.98. What is the ratio of the Imports(as % of merchandise exports) of Mauritius in 1975 to that in 2000?
Offer a terse response. 0.83. What is the ratio of the Imports(as % of merchandise exports) of Sierra Leone in 1975 to that in 2000?
Your response must be concise. 0.48. What is the ratio of the Imports(as % of merchandise exports) in Hong Kong in 1976 to that in 2000?
Your answer should be compact. 2.88. What is the ratio of the Imports(as % of merchandise exports) of Kuwait in 1976 to that in 2000?
Provide a short and direct response. 1.23. What is the ratio of the Imports(as % of merchandise exports) in Mauritius in 1976 to that in 2000?
Your response must be concise. 0.74. What is the ratio of the Imports(as % of merchandise exports) of Sierra Leone in 1976 to that in 2000?
Your response must be concise. 0.5. What is the difference between the highest and the second highest Imports(as % of merchandise exports) of Hong Kong?
Your answer should be very brief. 0.1. What is the difference between the highest and the second highest Imports(as % of merchandise exports) of Kuwait?
Ensure brevity in your answer.  0.21. What is the difference between the highest and the second highest Imports(as % of merchandise exports) in Mauritius?
Your answer should be compact. 1.99. What is the difference between the highest and the second highest Imports(as % of merchandise exports) of Sierra Leone?
Offer a very short reply. 14.13. What is the difference between the highest and the lowest Imports(as % of merchandise exports) in Hong Kong?
Ensure brevity in your answer.  4.2. What is the difference between the highest and the lowest Imports(as % of merchandise exports) in Kuwait?
Offer a terse response. 0.61. What is the difference between the highest and the lowest Imports(as % of merchandise exports) of Mauritius?
Your answer should be very brief. 4.83. What is the difference between the highest and the lowest Imports(as % of merchandise exports) of Sierra Leone?
Make the answer very short. 22.44. 